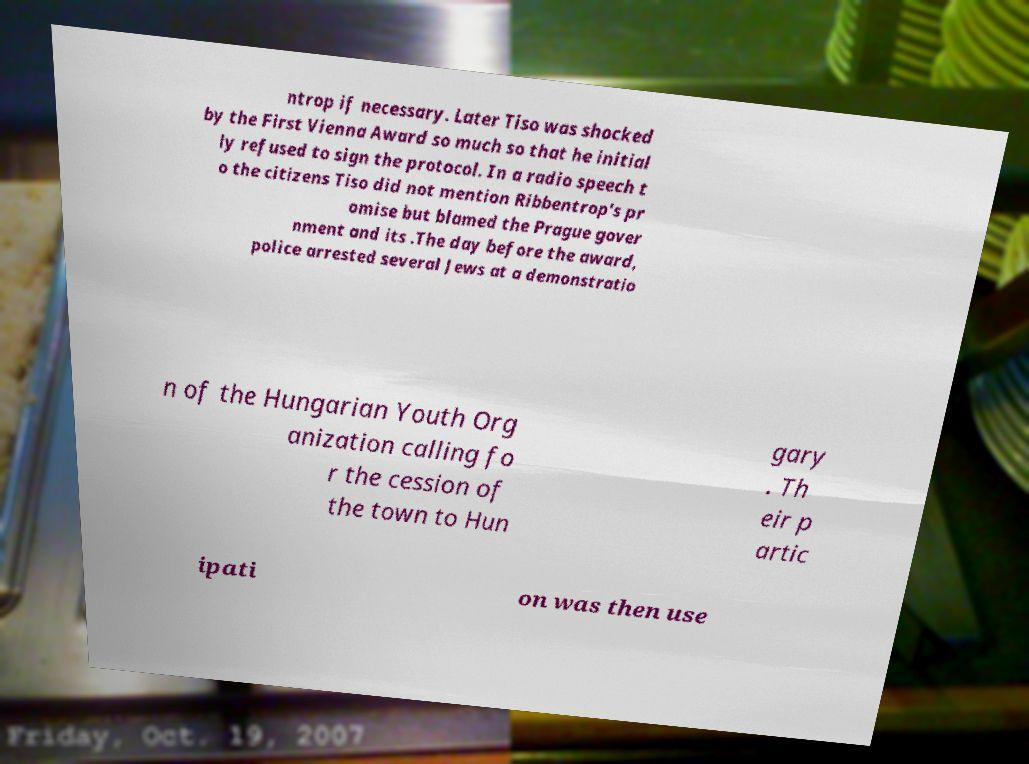What messages or text are displayed in this image? I need them in a readable, typed format. ntrop if necessary. Later Tiso was shocked by the First Vienna Award so much so that he initial ly refused to sign the protocol. In a radio speech t o the citizens Tiso did not mention Ribbentrop's pr omise but blamed the Prague gover nment and its .The day before the award, police arrested several Jews at a demonstratio n of the Hungarian Youth Org anization calling fo r the cession of the town to Hun gary . Th eir p artic ipati on was then use 